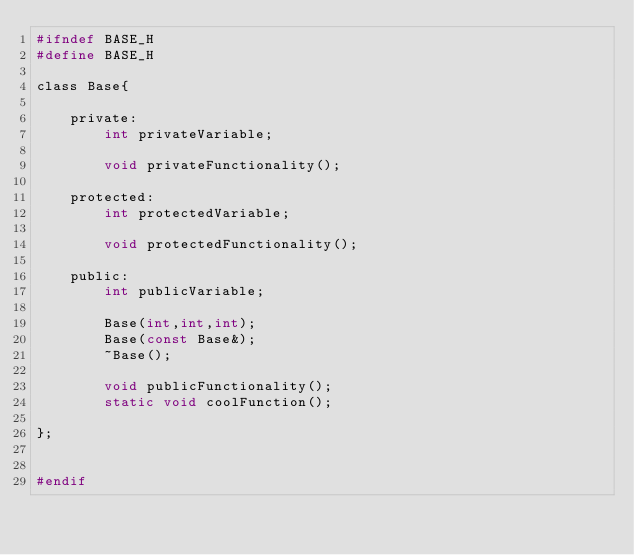<code> <loc_0><loc_0><loc_500><loc_500><_C_>#ifndef BASE_H
#define BASE_H

class Base{

    private:
        int privateVariable;

        void privateFunctionality();
    
    protected:
        int protectedVariable;

        void protectedFunctionality();
    
    public:
        int publicVariable;

        Base(int,int,int);
        Base(const Base&);
        ~Base();

        void publicFunctionality();
        static void coolFunction();

};


#endif</code> 